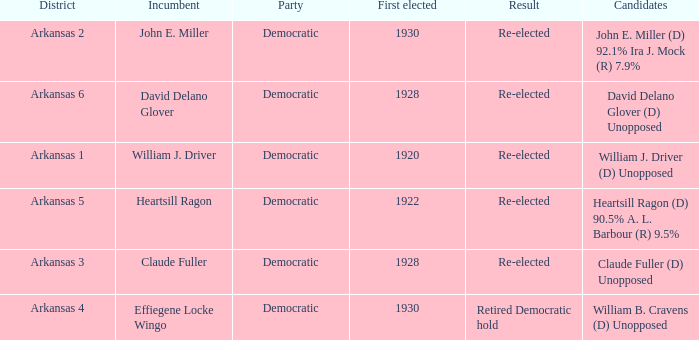In which district was john e. miller the current officeholder? Arkansas 2. 